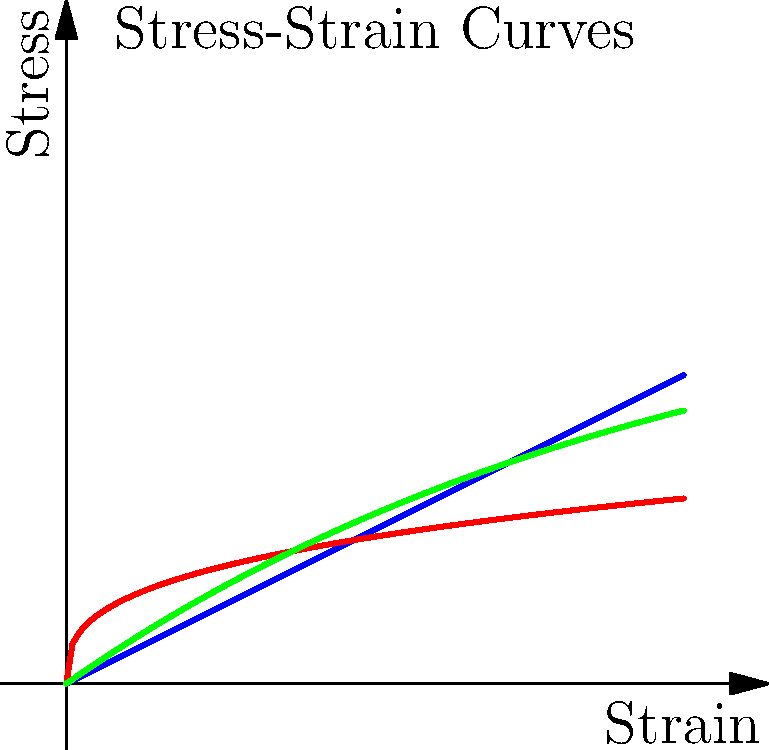As a vocal coach with experience in resonance and tension, which of the stress-strain curves (A, B, or C) would most likely represent the behavior of a ductile material like steel, often used in opera house construction for its ability to withstand tension without sudden failure? Let's analyze each curve in relation to ductile materials like steel:

1. Curve A (blue): This is a straight line, indicating a linear relationship between stress and strain. While steel does have an initial linear elastic region, it doesn't represent the full behavior of a ductile material.

2. Curve B (red): This curve shows a rapid initial increase in stress with strain, followed by a more gradual increase. This doesn't accurately represent the behavior of steel or other ductile materials.

3. Curve C (green): This curve best represents a ductile material like steel:
   a. It has an initial linear region (elastic deformation).
   b. The curve then bends, indicating the yield point where plastic deformation begins.
   c. After yielding, the stress continues to increase but at a decreasing rate, showing strain hardening.
   d. The curve doesn't have a sudden drop, indicating the material's ability to undergo large deformations without sudden failure.

This behavior is crucial in construction, especially for opera houses, where materials need to withstand various stresses without catastrophic failure. Steel's ductility allows it to redistribute stress and provide warning before failure, much like how a singer's voice can adapt to different vocal demands without sudden strain.
Answer: C 